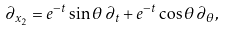<formula> <loc_0><loc_0><loc_500><loc_500>\partial _ { x _ { 2 } } = e ^ { - t } \sin \theta \, \partial _ { t } + e ^ { - t } \cos \theta \, \partial _ { \theta } ,</formula> 